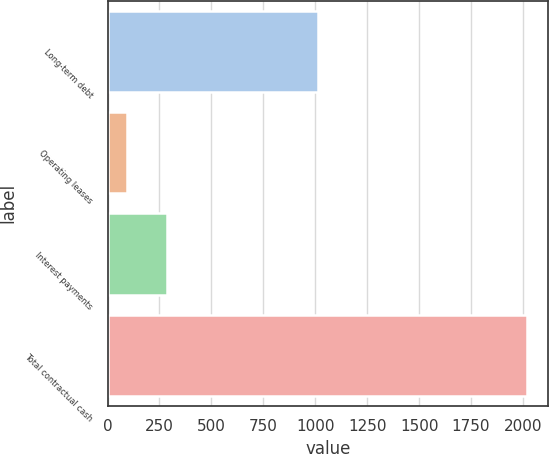Convert chart to OTSL. <chart><loc_0><loc_0><loc_500><loc_500><bar_chart><fcel>Long-term debt<fcel>Operating leases<fcel>Interest payments<fcel>Total contractual cash<nl><fcel>1013.5<fcel>92.3<fcel>285.25<fcel>2021.8<nl></chart> 